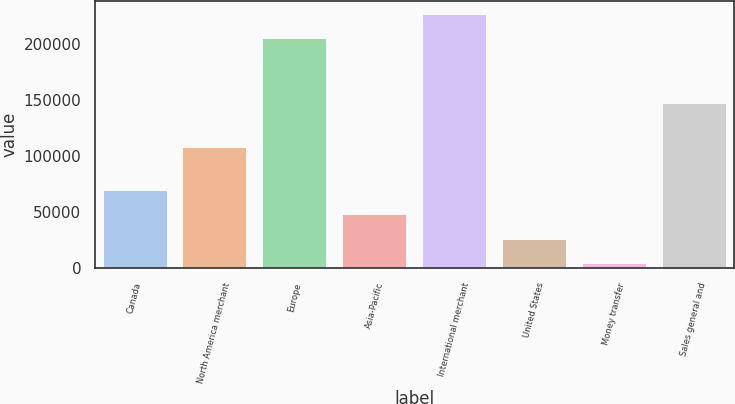<chart> <loc_0><loc_0><loc_500><loc_500><bar_chart><fcel>Canada<fcel>North America merchant<fcel>Europe<fcel>Asia-Pacific<fcel>International merchant<fcel>United States<fcel>Money transfer<fcel>Sales general and<nl><fcel>70074.4<fcel>108387<fcel>205343<fcel>48183.6<fcel>227234<fcel>26292.8<fcel>4402<fcel>147705<nl></chart> 